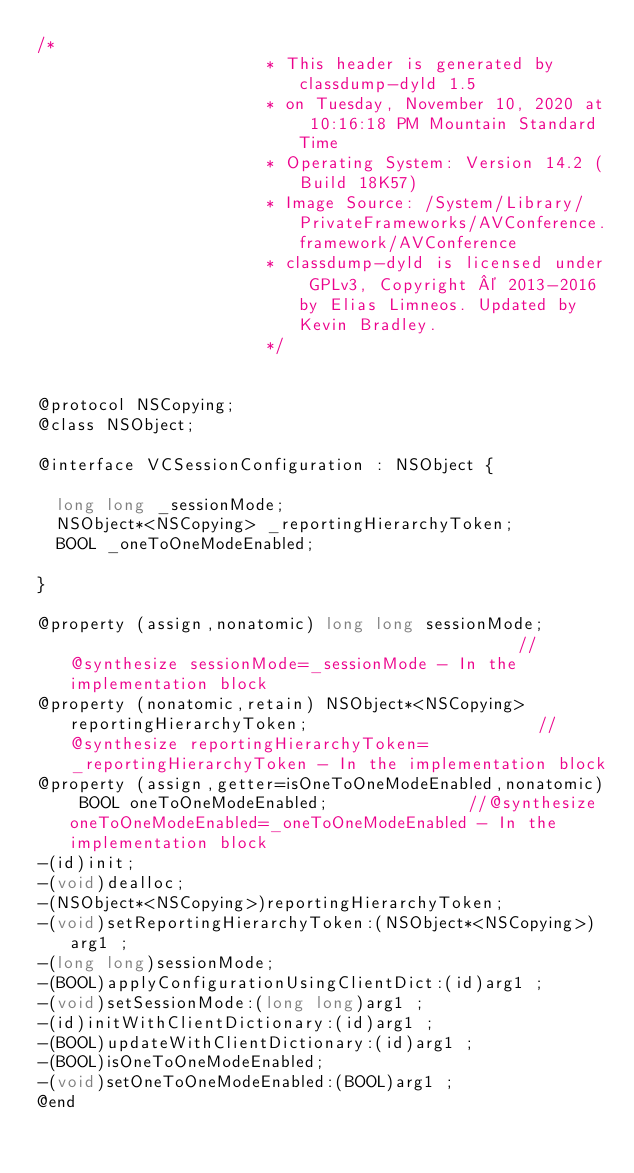<code> <loc_0><loc_0><loc_500><loc_500><_C_>/*
                       * This header is generated by classdump-dyld 1.5
                       * on Tuesday, November 10, 2020 at 10:16:18 PM Mountain Standard Time
                       * Operating System: Version 14.2 (Build 18K57)
                       * Image Source: /System/Library/PrivateFrameworks/AVConference.framework/AVConference
                       * classdump-dyld is licensed under GPLv3, Copyright © 2013-2016 by Elias Limneos. Updated by Kevin Bradley.
                       */


@protocol NSCopying;
@class NSObject;

@interface VCSessionConfiguration : NSObject {

	long long _sessionMode;
	NSObject*<NSCopying> _reportingHierarchyToken;
	BOOL _oneToOneModeEnabled;

}

@property (assign,nonatomic) long long sessionMode;                                              //@synthesize sessionMode=_sessionMode - In the implementation block
@property (nonatomic,retain) NSObject*<NSCopying> reportingHierarchyToken;                       //@synthesize reportingHierarchyToken=_reportingHierarchyToken - In the implementation block
@property (assign,getter=isOneToOneModeEnabled,nonatomic) BOOL oneToOneModeEnabled;              //@synthesize oneToOneModeEnabled=_oneToOneModeEnabled - In the implementation block
-(id)init;
-(void)dealloc;
-(NSObject*<NSCopying>)reportingHierarchyToken;
-(void)setReportingHierarchyToken:(NSObject*<NSCopying>)arg1 ;
-(long long)sessionMode;
-(BOOL)applyConfigurationUsingClientDict:(id)arg1 ;
-(void)setSessionMode:(long long)arg1 ;
-(id)initWithClientDictionary:(id)arg1 ;
-(BOOL)updateWithClientDictionary:(id)arg1 ;
-(BOOL)isOneToOneModeEnabled;
-(void)setOneToOneModeEnabled:(BOOL)arg1 ;
@end

</code> 